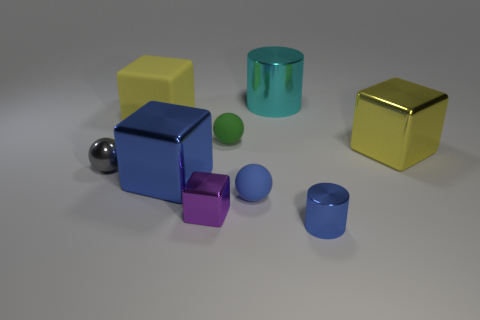There is a metallic thing that is both behind the small gray metallic thing and in front of the large cyan object; how big is it?
Your answer should be compact. Large. How many metal things are the same color as the large rubber object?
Offer a very short reply. 1. The blue cylinder that is made of the same material as the large blue cube is what size?
Your response must be concise. Small. The rubber thing that is behind the green rubber ball has what shape?
Your answer should be compact. Cube. What size is the yellow matte thing that is the same shape as the big blue thing?
Your answer should be very brief. Large. There is a rubber cube on the left side of the metal object right of the tiny cylinder; what number of gray metallic spheres are on the left side of it?
Your answer should be very brief. 1. Are there an equal number of tiny gray metallic balls on the left side of the small metal ball and small blue cylinders?
Give a very brief answer. No. What number of cylinders are small green rubber things or large blue shiny things?
Give a very brief answer. 0. Is the number of large yellow things behind the big yellow shiny cube the same as the number of yellow shiny blocks that are on the left side of the gray object?
Ensure brevity in your answer.  No. What is the color of the small metallic block?
Offer a terse response. Purple. 